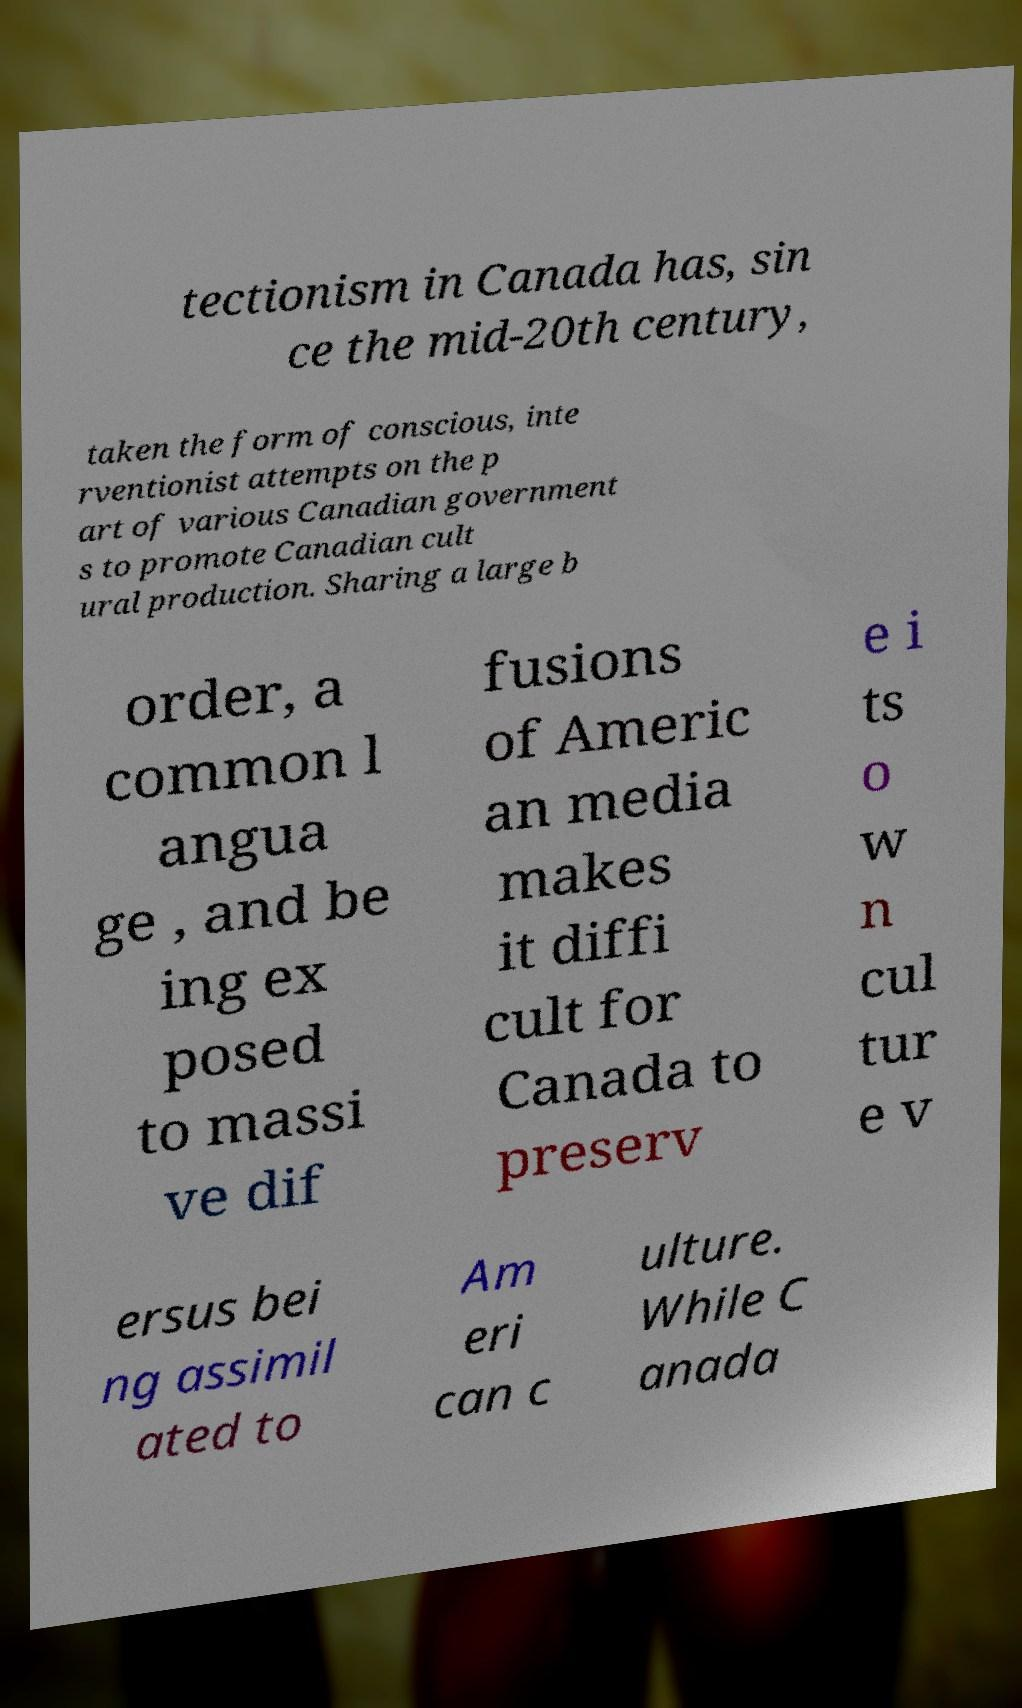Can you accurately transcribe the text from the provided image for me? tectionism in Canada has, sin ce the mid-20th century, taken the form of conscious, inte rventionist attempts on the p art of various Canadian government s to promote Canadian cult ural production. Sharing a large b order, a common l angua ge , and be ing ex posed to massi ve dif fusions of Americ an media makes it diffi cult for Canada to preserv e i ts o w n cul tur e v ersus bei ng assimil ated to Am eri can c ulture. While C anada 